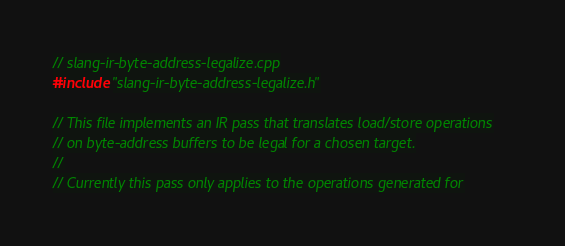<code> <loc_0><loc_0><loc_500><loc_500><_C++_>// slang-ir-byte-address-legalize.cpp
#include "slang-ir-byte-address-legalize.h"

// This file implements an IR pass that translates load/store operations
// on byte-address buffers to be legal for a chosen target.
//
// Currently this pass only applies to the operations generated for</code> 